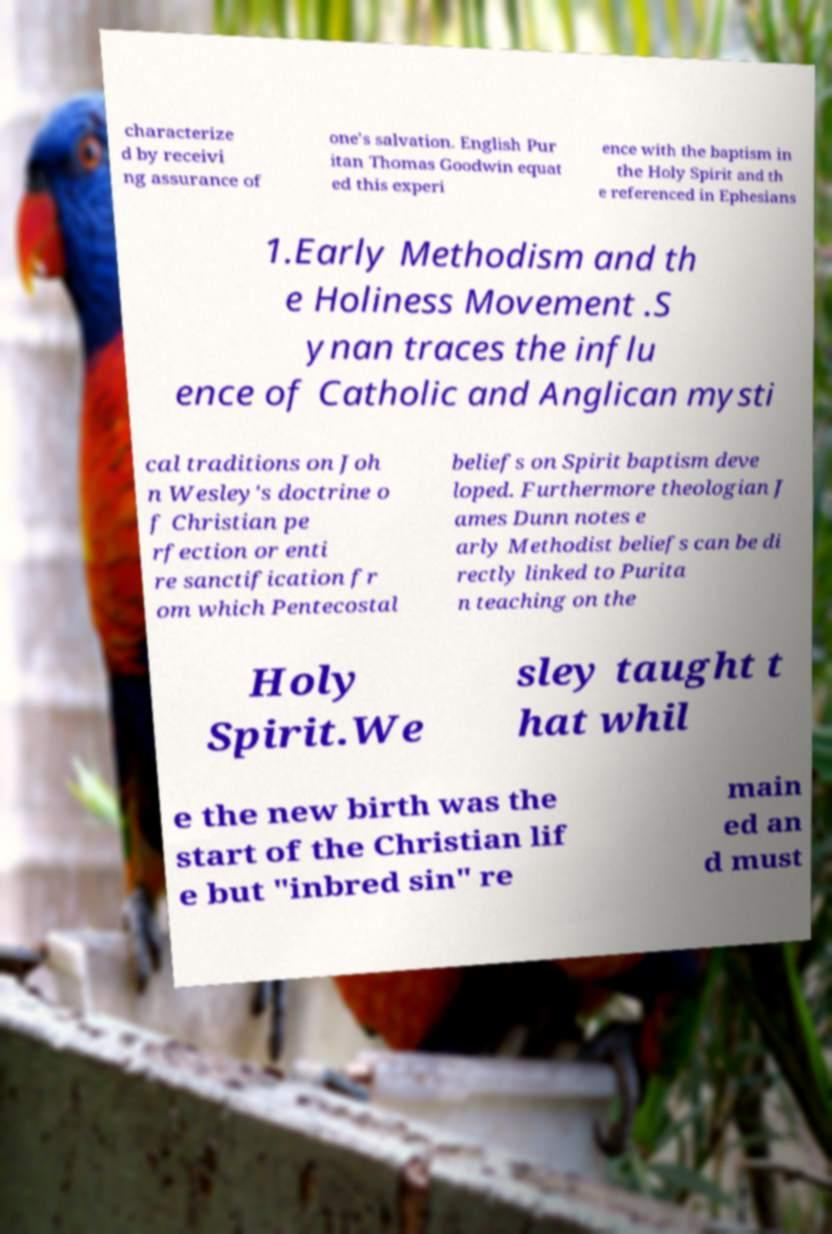Please identify and transcribe the text found in this image. characterize d by receivi ng assurance of one's salvation. English Pur itan Thomas Goodwin equat ed this experi ence with the baptism in the Holy Spirit and th e referenced in Ephesians 1.Early Methodism and th e Holiness Movement .S ynan traces the influ ence of Catholic and Anglican mysti cal traditions on Joh n Wesley's doctrine o f Christian pe rfection or enti re sanctification fr om which Pentecostal beliefs on Spirit baptism deve loped. Furthermore theologian J ames Dunn notes e arly Methodist beliefs can be di rectly linked to Purita n teaching on the Holy Spirit.We sley taught t hat whil e the new birth was the start of the Christian lif e but "inbred sin" re main ed an d must 